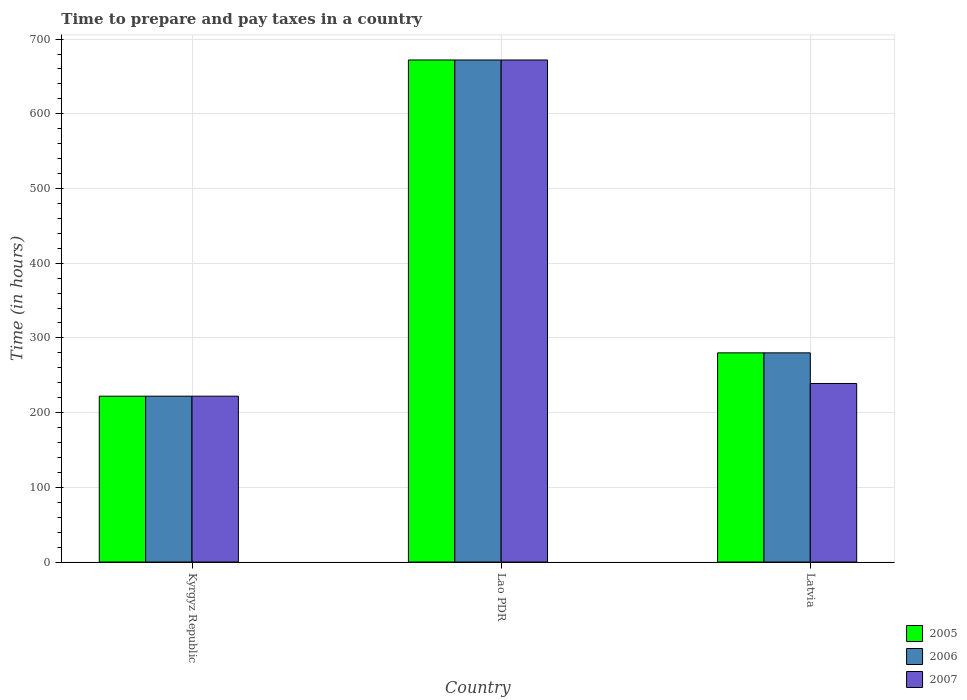How many bars are there on the 2nd tick from the left?
Offer a terse response. 3. How many bars are there on the 1st tick from the right?
Provide a succinct answer. 3. What is the label of the 1st group of bars from the left?
Give a very brief answer. Kyrgyz Republic. In how many cases, is the number of bars for a given country not equal to the number of legend labels?
Offer a terse response. 0. What is the number of hours required to prepare and pay taxes in 2005 in Lao PDR?
Keep it short and to the point. 672. Across all countries, what is the maximum number of hours required to prepare and pay taxes in 2005?
Your response must be concise. 672. Across all countries, what is the minimum number of hours required to prepare and pay taxes in 2006?
Your answer should be very brief. 222. In which country was the number of hours required to prepare and pay taxes in 2006 maximum?
Offer a terse response. Lao PDR. In which country was the number of hours required to prepare and pay taxes in 2005 minimum?
Your response must be concise. Kyrgyz Republic. What is the total number of hours required to prepare and pay taxes in 2005 in the graph?
Offer a terse response. 1174. What is the difference between the number of hours required to prepare and pay taxes in 2007 in Kyrgyz Republic and that in Lao PDR?
Offer a very short reply. -450. What is the difference between the number of hours required to prepare and pay taxes in 2006 in Lao PDR and the number of hours required to prepare and pay taxes in 2005 in Kyrgyz Republic?
Your response must be concise. 450. What is the average number of hours required to prepare and pay taxes in 2007 per country?
Give a very brief answer. 377.67. In how many countries, is the number of hours required to prepare and pay taxes in 2005 greater than 640 hours?
Give a very brief answer. 1. What is the ratio of the number of hours required to prepare and pay taxes in 2006 in Kyrgyz Republic to that in Lao PDR?
Provide a short and direct response. 0.33. What is the difference between the highest and the second highest number of hours required to prepare and pay taxes in 2006?
Your response must be concise. 392. What is the difference between the highest and the lowest number of hours required to prepare and pay taxes in 2006?
Your response must be concise. 450. In how many countries, is the number of hours required to prepare and pay taxes in 2005 greater than the average number of hours required to prepare and pay taxes in 2005 taken over all countries?
Offer a terse response. 1. How many bars are there?
Provide a short and direct response. 9. Are the values on the major ticks of Y-axis written in scientific E-notation?
Provide a succinct answer. No. Where does the legend appear in the graph?
Your answer should be compact. Bottom right. What is the title of the graph?
Keep it short and to the point. Time to prepare and pay taxes in a country. Does "2006" appear as one of the legend labels in the graph?
Make the answer very short. Yes. What is the label or title of the X-axis?
Your answer should be compact. Country. What is the label or title of the Y-axis?
Make the answer very short. Time (in hours). What is the Time (in hours) of 2005 in Kyrgyz Republic?
Your answer should be very brief. 222. What is the Time (in hours) in 2006 in Kyrgyz Republic?
Your answer should be very brief. 222. What is the Time (in hours) in 2007 in Kyrgyz Republic?
Your response must be concise. 222. What is the Time (in hours) of 2005 in Lao PDR?
Make the answer very short. 672. What is the Time (in hours) in 2006 in Lao PDR?
Make the answer very short. 672. What is the Time (in hours) in 2007 in Lao PDR?
Your answer should be compact. 672. What is the Time (in hours) of 2005 in Latvia?
Keep it short and to the point. 280. What is the Time (in hours) in 2006 in Latvia?
Your response must be concise. 280. What is the Time (in hours) in 2007 in Latvia?
Ensure brevity in your answer.  239. Across all countries, what is the maximum Time (in hours) of 2005?
Ensure brevity in your answer.  672. Across all countries, what is the maximum Time (in hours) of 2006?
Offer a terse response. 672. Across all countries, what is the maximum Time (in hours) of 2007?
Provide a succinct answer. 672. Across all countries, what is the minimum Time (in hours) of 2005?
Offer a very short reply. 222. Across all countries, what is the minimum Time (in hours) of 2006?
Keep it short and to the point. 222. Across all countries, what is the minimum Time (in hours) in 2007?
Offer a very short reply. 222. What is the total Time (in hours) of 2005 in the graph?
Give a very brief answer. 1174. What is the total Time (in hours) of 2006 in the graph?
Your response must be concise. 1174. What is the total Time (in hours) of 2007 in the graph?
Keep it short and to the point. 1133. What is the difference between the Time (in hours) in 2005 in Kyrgyz Republic and that in Lao PDR?
Keep it short and to the point. -450. What is the difference between the Time (in hours) in 2006 in Kyrgyz Republic and that in Lao PDR?
Your answer should be compact. -450. What is the difference between the Time (in hours) of 2007 in Kyrgyz Republic and that in Lao PDR?
Keep it short and to the point. -450. What is the difference between the Time (in hours) in 2005 in Kyrgyz Republic and that in Latvia?
Your answer should be compact. -58. What is the difference between the Time (in hours) of 2006 in Kyrgyz Republic and that in Latvia?
Offer a very short reply. -58. What is the difference between the Time (in hours) in 2005 in Lao PDR and that in Latvia?
Your answer should be very brief. 392. What is the difference between the Time (in hours) in 2006 in Lao PDR and that in Latvia?
Your answer should be compact. 392. What is the difference between the Time (in hours) of 2007 in Lao PDR and that in Latvia?
Keep it short and to the point. 433. What is the difference between the Time (in hours) in 2005 in Kyrgyz Republic and the Time (in hours) in 2006 in Lao PDR?
Keep it short and to the point. -450. What is the difference between the Time (in hours) of 2005 in Kyrgyz Republic and the Time (in hours) of 2007 in Lao PDR?
Offer a very short reply. -450. What is the difference between the Time (in hours) of 2006 in Kyrgyz Republic and the Time (in hours) of 2007 in Lao PDR?
Your answer should be very brief. -450. What is the difference between the Time (in hours) of 2005 in Kyrgyz Republic and the Time (in hours) of 2006 in Latvia?
Make the answer very short. -58. What is the difference between the Time (in hours) in 2006 in Kyrgyz Republic and the Time (in hours) in 2007 in Latvia?
Your answer should be very brief. -17. What is the difference between the Time (in hours) in 2005 in Lao PDR and the Time (in hours) in 2006 in Latvia?
Keep it short and to the point. 392. What is the difference between the Time (in hours) of 2005 in Lao PDR and the Time (in hours) of 2007 in Latvia?
Your answer should be very brief. 433. What is the difference between the Time (in hours) in 2006 in Lao PDR and the Time (in hours) in 2007 in Latvia?
Provide a short and direct response. 433. What is the average Time (in hours) of 2005 per country?
Offer a terse response. 391.33. What is the average Time (in hours) of 2006 per country?
Provide a short and direct response. 391.33. What is the average Time (in hours) of 2007 per country?
Provide a short and direct response. 377.67. What is the difference between the Time (in hours) in 2005 and Time (in hours) in 2006 in Kyrgyz Republic?
Give a very brief answer. 0. What is the difference between the Time (in hours) in 2006 and Time (in hours) in 2007 in Kyrgyz Republic?
Your response must be concise. 0. What is the difference between the Time (in hours) in 2005 and Time (in hours) in 2006 in Latvia?
Keep it short and to the point. 0. What is the difference between the Time (in hours) of 2005 and Time (in hours) of 2007 in Latvia?
Your answer should be compact. 41. What is the difference between the Time (in hours) in 2006 and Time (in hours) in 2007 in Latvia?
Give a very brief answer. 41. What is the ratio of the Time (in hours) in 2005 in Kyrgyz Republic to that in Lao PDR?
Make the answer very short. 0.33. What is the ratio of the Time (in hours) of 2006 in Kyrgyz Republic to that in Lao PDR?
Your answer should be very brief. 0.33. What is the ratio of the Time (in hours) in 2007 in Kyrgyz Republic to that in Lao PDR?
Offer a terse response. 0.33. What is the ratio of the Time (in hours) of 2005 in Kyrgyz Republic to that in Latvia?
Offer a very short reply. 0.79. What is the ratio of the Time (in hours) of 2006 in Kyrgyz Republic to that in Latvia?
Your answer should be very brief. 0.79. What is the ratio of the Time (in hours) in 2007 in Kyrgyz Republic to that in Latvia?
Provide a succinct answer. 0.93. What is the ratio of the Time (in hours) in 2006 in Lao PDR to that in Latvia?
Offer a terse response. 2.4. What is the ratio of the Time (in hours) in 2007 in Lao PDR to that in Latvia?
Provide a succinct answer. 2.81. What is the difference between the highest and the second highest Time (in hours) in 2005?
Make the answer very short. 392. What is the difference between the highest and the second highest Time (in hours) in 2006?
Your answer should be very brief. 392. What is the difference between the highest and the second highest Time (in hours) of 2007?
Your answer should be compact. 433. What is the difference between the highest and the lowest Time (in hours) of 2005?
Offer a terse response. 450. What is the difference between the highest and the lowest Time (in hours) in 2006?
Ensure brevity in your answer.  450. What is the difference between the highest and the lowest Time (in hours) in 2007?
Your response must be concise. 450. 